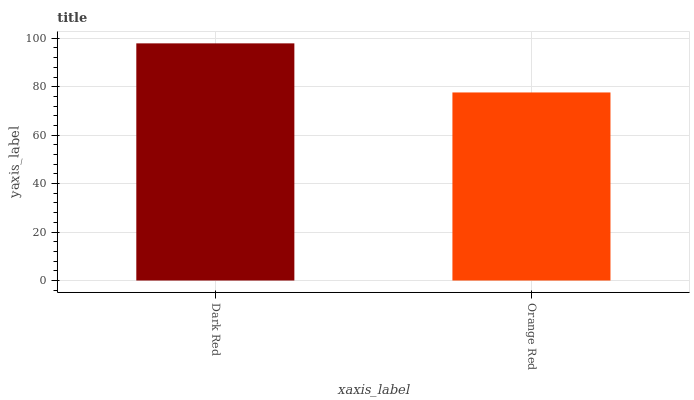Is Orange Red the minimum?
Answer yes or no. Yes. Is Dark Red the maximum?
Answer yes or no. Yes. Is Orange Red the maximum?
Answer yes or no. No. Is Dark Red greater than Orange Red?
Answer yes or no. Yes. Is Orange Red less than Dark Red?
Answer yes or no. Yes. Is Orange Red greater than Dark Red?
Answer yes or no. No. Is Dark Red less than Orange Red?
Answer yes or no. No. Is Dark Red the high median?
Answer yes or no. Yes. Is Orange Red the low median?
Answer yes or no. Yes. Is Orange Red the high median?
Answer yes or no. No. Is Dark Red the low median?
Answer yes or no. No. 